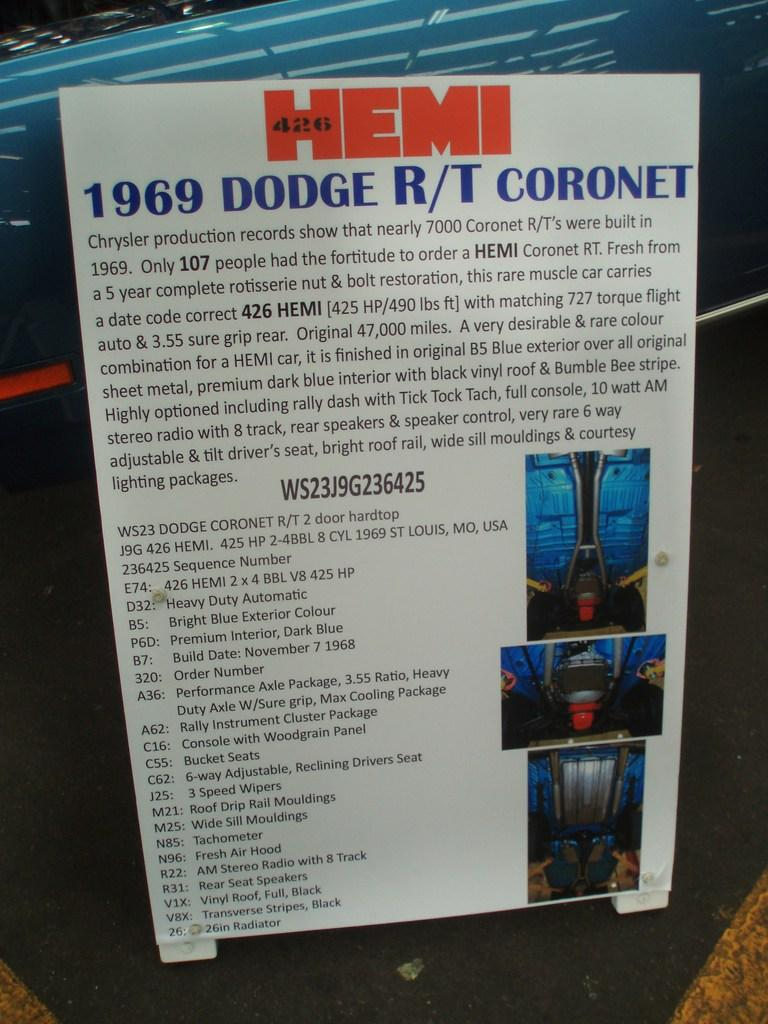Provide a one-sentence caption for the provided image. Text describing a coronet from 1969 and magonified in part. 